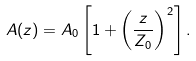Convert formula to latex. <formula><loc_0><loc_0><loc_500><loc_500>A ( z ) = A _ { 0 } \left [ 1 + \left ( \frac { z } { Z _ { 0 } } \right ) ^ { 2 } \right ] .</formula> 